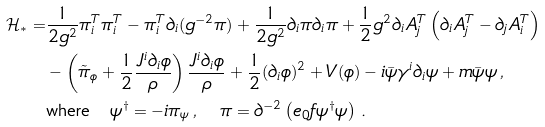<formula> <loc_0><loc_0><loc_500><loc_500>\mathcal { H } _ { * } = & \frac { 1 } { 2 g ^ { 2 } } \pi _ { i } ^ { T } \pi _ { i } ^ { T } - \pi _ { i } ^ { T } \partial _ { i } ( g ^ { - 2 } \pi ) + \frac { 1 } { 2 g ^ { 2 } } \partial _ { i } \pi \partial _ { i } \pi + \frac { 1 } { 2 } g ^ { 2 } \partial _ { i } A _ { j } ^ { T } \left ( \partial _ { i } A _ { j } ^ { T } - \partial _ { j } A _ { i } ^ { T } \right ) \\ & - \left ( \tilde { \pi } _ { \phi } + \frac { 1 } { 2 } \frac { J ^ { i } \partial _ { i } \phi } { \rho } \right ) \frac { J ^ { i } \partial _ { i } \phi } { \rho } + \frac { 1 } { 2 } ( \partial _ { i } \phi ) ^ { 2 } + V ( \phi ) - i \bar { \psi } \gamma ^ { i } \partial _ { i } \psi + m \bar { \psi } \psi \, , \\ & \text {where} \quad \psi ^ { \dag } = - i \pi _ { \psi } \, , \quad \pi = \partial ^ { - 2 } \left ( e _ { 0 } f \psi ^ { \dagger } \psi \right ) \, .</formula> 